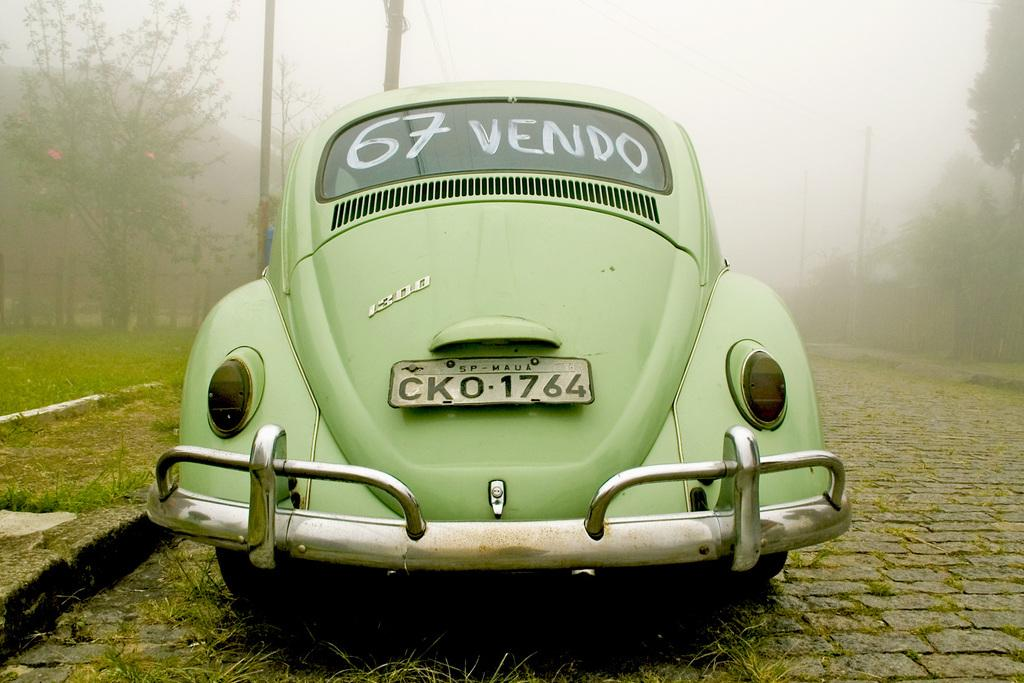Where was the image taken? The image was clicked outside. What is the main subject in the middle of the image? There is a car in the middle of the image. What type of vegetation can be seen on both sides of the image? There are trees on the left side and right side of the image. What is visible at the top of the image? The sky is visible at the top of the image. What type of ground is visible at the bottom of the image? There is grass at the bottom of the image. How many snakes are slithering through the car in the image? There are no snakes present in the image; the car is the main subject in the middle of the image. What is the shape of the heart visible in the image? There is no heart visible in the image; the focus is on the car, trees, sky, and grass. 